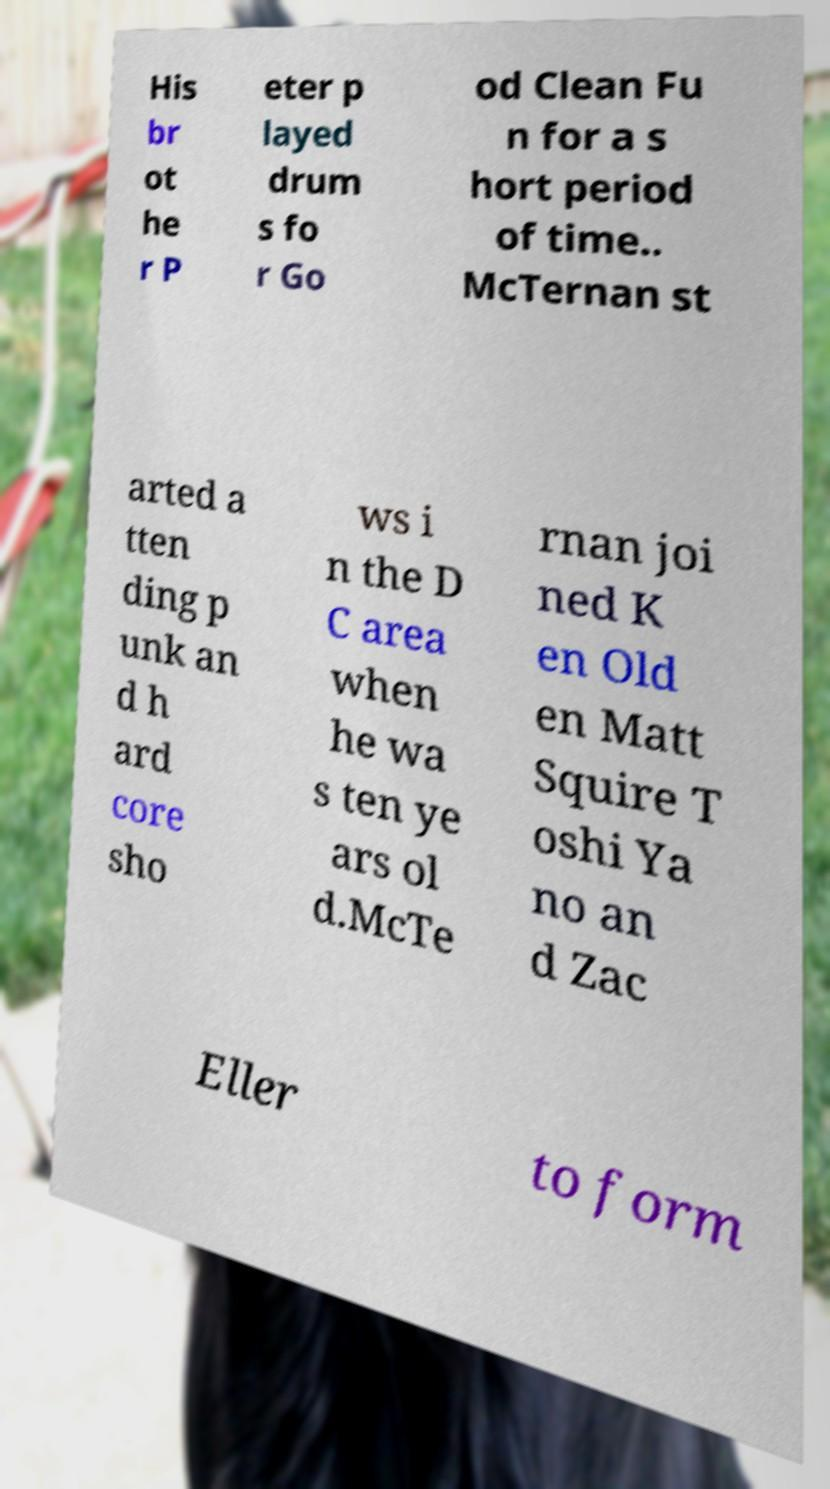Please read and relay the text visible in this image. What does it say? His br ot he r P eter p layed drum s fo r Go od Clean Fu n for a s hort period of time.. McTernan st arted a tten ding p unk an d h ard core sho ws i n the D C area when he wa s ten ye ars ol d.McTe rnan joi ned K en Old en Matt Squire T oshi Ya no an d Zac Eller to form 